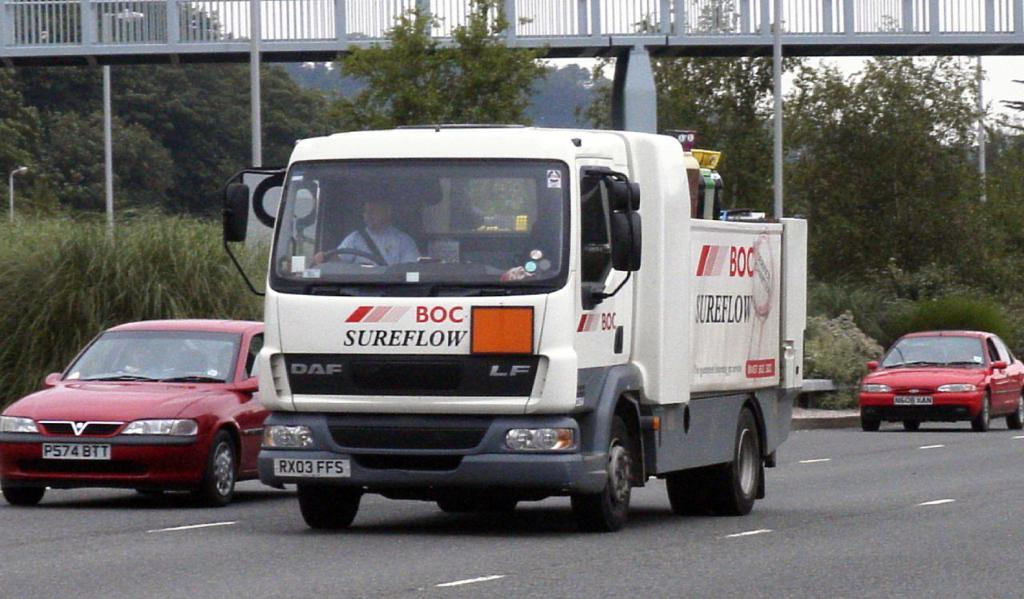What type of vehicle is in the image? There is a white truck in the image. What is the truck doing in the image? The truck is moving on the road. What other vehicles are visible in the image? There are red cars behind the truck. What natural elements can be seen in the image? There are trees visible in the image. What type of structure is present in the image? There is a crossing bridge with iron railing in the image. What type of detail can be seen on the tree in the image? There is no tree present in the image; it only mentions trees as a natural element visible in the background. 